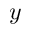<formula> <loc_0><loc_0><loc_500><loc_500>y</formula> 